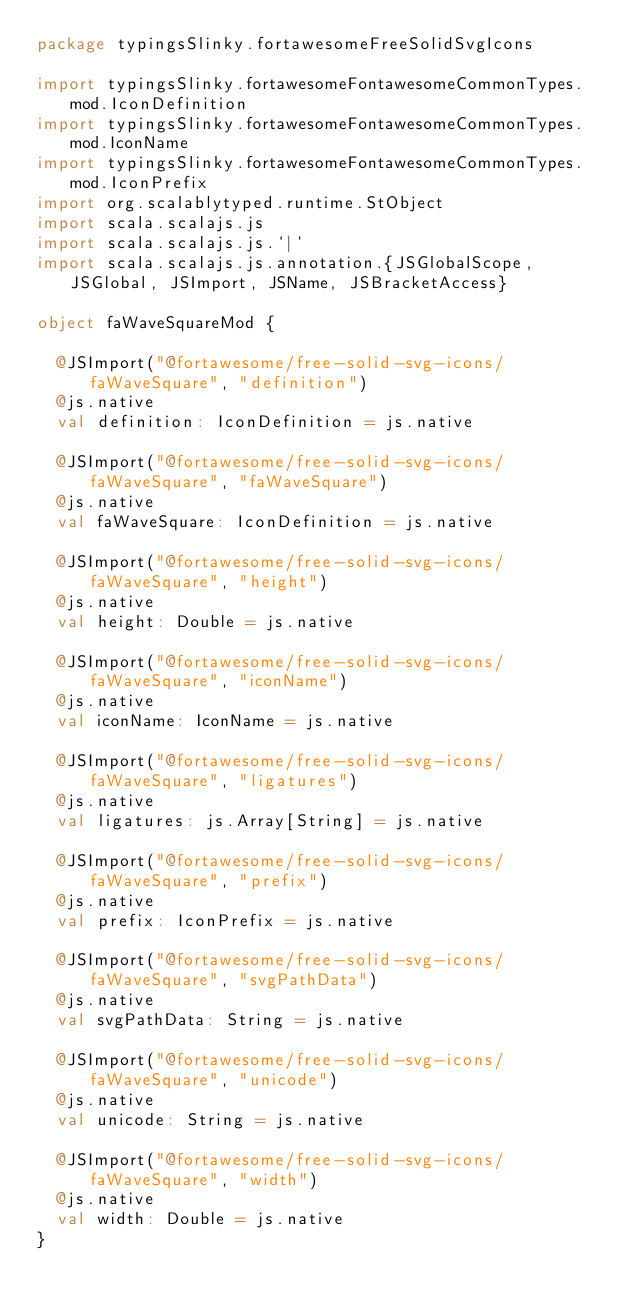<code> <loc_0><loc_0><loc_500><loc_500><_Scala_>package typingsSlinky.fortawesomeFreeSolidSvgIcons

import typingsSlinky.fortawesomeFontawesomeCommonTypes.mod.IconDefinition
import typingsSlinky.fortawesomeFontawesomeCommonTypes.mod.IconName
import typingsSlinky.fortawesomeFontawesomeCommonTypes.mod.IconPrefix
import org.scalablytyped.runtime.StObject
import scala.scalajs.js
import scala.scalajs.js.`|`
import scala.scalajs.js.annotation.{JSGlobalScope, JSGlobal, JSImport, JSName, JSBracketAccess}

object faWaveSquareMod {
  
  @JSImport("@fortawesome/free-solid-svg-icons/faWaveSquare", "definition")
  @js.native
  val definition: IconDefinition = js.native
  
  @JSImport("@fortawesome/free-solid-svg-icons/faWaveSquare", "faWaveSquare")
  @js.native
  val faWaveSquare: IconDefinition = js.native
  
  @JSImport("@fortawesome/free-solid-svg-icons/faWaveSquare", "height")
  @js.native
  val height: Double = js.native
  
  @JSImport("@fortawesome/free-solid-svg-icons/faWaveSquare", "iconName")
  @js.native
  val iconName: IconName = js.native
  
  @JSImport("@fortawesome/free-solid-svg-icons/faWaveSquare", "ligatures")
  @js.native
  val ligatures: js.Array[String] = js.native
  
  @JSImport("@fortawesome/free-solid-svg-icons/faWaveSquare", "prefix")
  @js.native
  val prefix: IconPrefix = js.native
  
  @JSImport("@fortawesome/free-solid-svg-icons/faWaveSquare", "svgPathData")
  @js.native
  val svgPathData: String = js.native
  
  @JSImport("@fortawesome/free-solid-svg-icons/faWaveSquare", "unicode")
  @js.native
  val unicode: String = js.native
  
  @JSImport("@fortawesome/free-solid-svg-icons/faWaveSquare", "width")
  @js.native
  val width: Double = js.native
}
</code> 